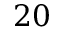<formula> <loc_0><loc_0><loc_500><loc_500>2 0</formula> 